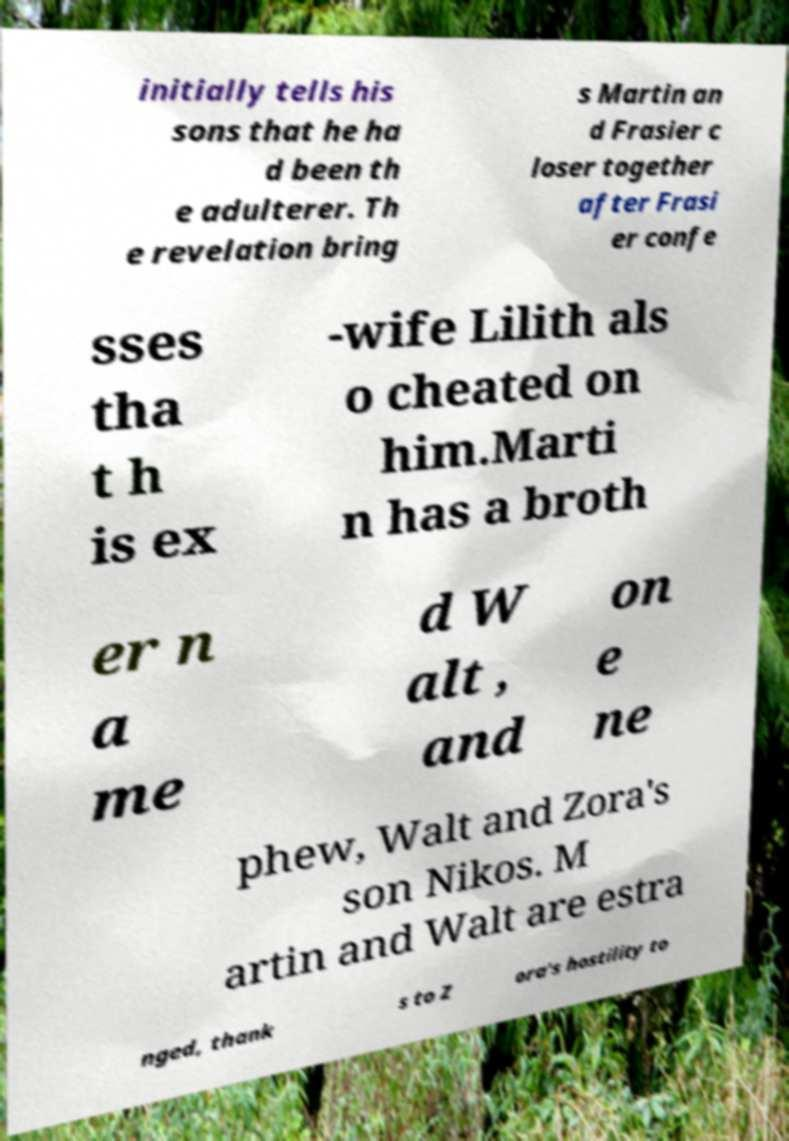I need the written content from this picture converted into text. Can you do that? initially tells his sons that he ha d been th e adulterer. Th e revelation bring s Martin an d Frasier c loser together after Frasi er confe sses tha t h is ex -wife Lilith als o cheated on him.Marti n has a broth er n a me d W alt , and on e ne phew, Walt and Zora's son Nikos. M artin and Walt are estra nged, thank s to Z ora's hostility to 